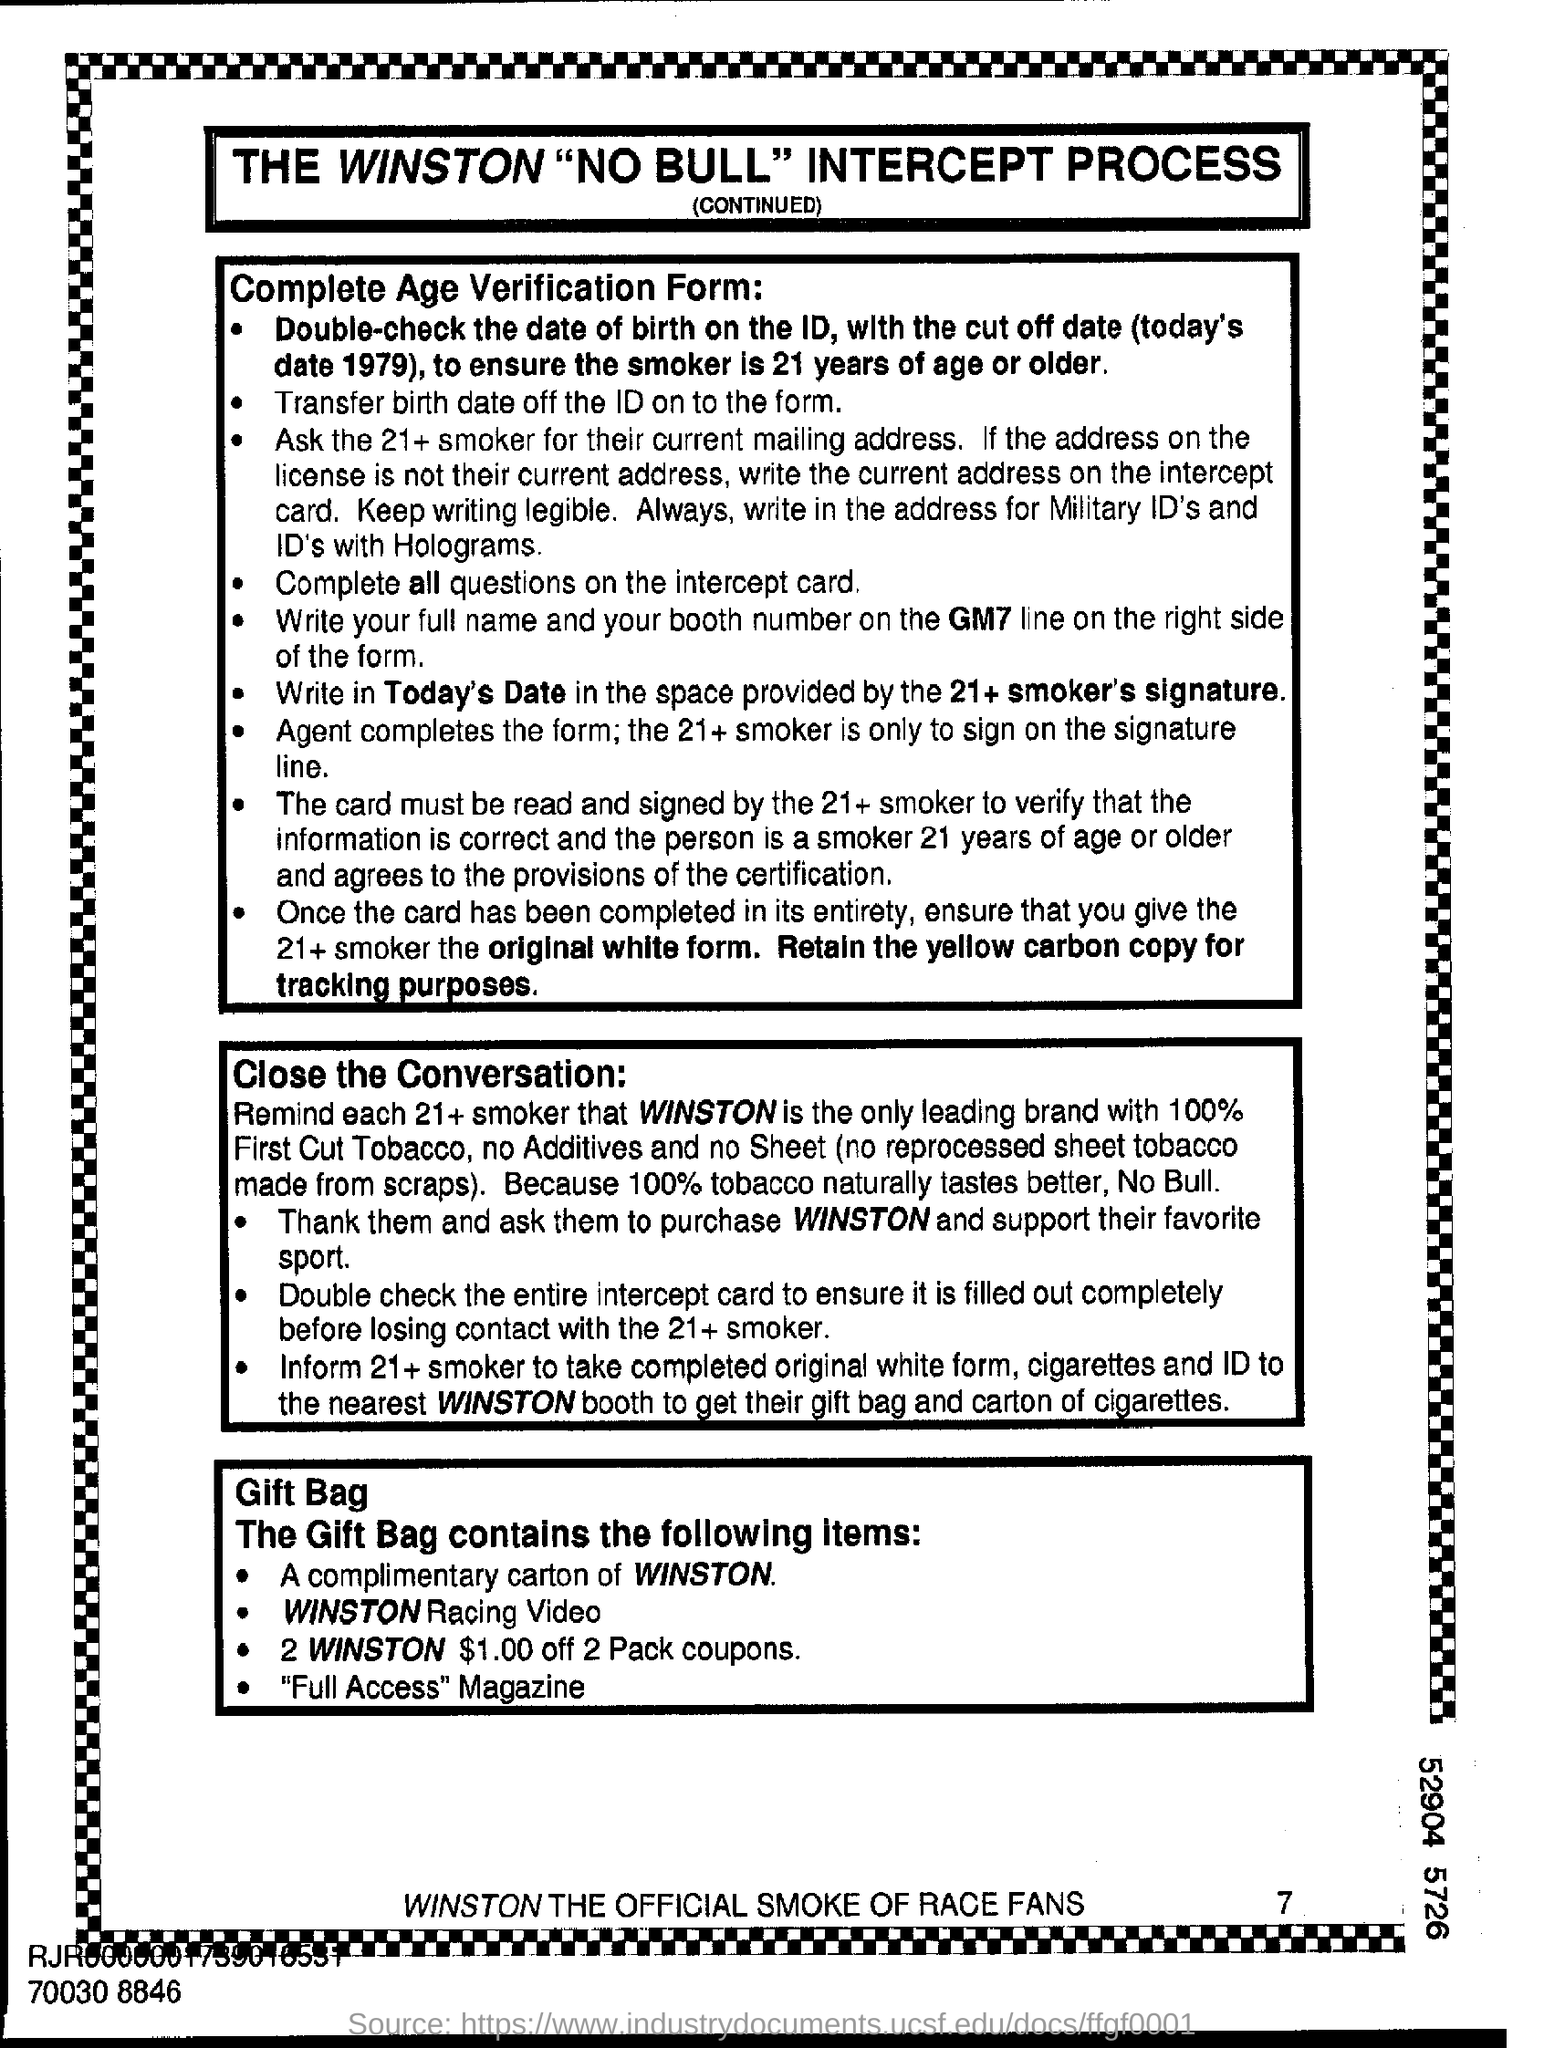Which Magazine does the gift bag have?
Your answer should be compact. "Full Access". 